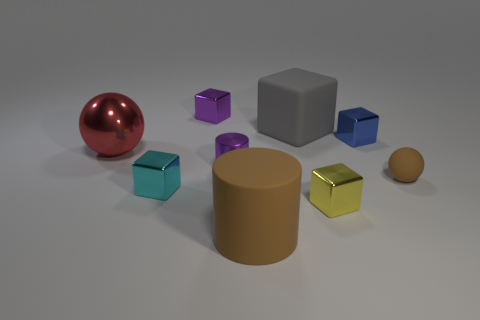What number of objects are either large matte things in front of the yellow cube or large matte cylinders?
Offer a terse response. 1. What is the material of the tiny cyan block in front of the brown object that is right of the yellow block?
Your answer should be compact. Metal. Is there a large metallic thing of the same shape as the small rubber thing?
Your response must be concise. Yes. There is a yellow cube; does it have the same size as the purple thing in front of the big red shiny object?
Provide a succinct answer. Yes. What number of objects are big brown cylinders left of the rubber sphere or tiny shiny objects in front of the gray rubber thing?
Provide a short and direct response. 5. Is the number of balls that are to the left of the small cyan shiny block greater than the number of large brown cubes?
Ensure brevity in your answer.  Yes. How many blue cylinders have the same size as the cyan metallic block?
Keep it short and to the point. 0. Does the ball in front of the red sphere have the same size as the yellow object in front of the tiny brown matte thing?
Your answer should be compact. Yes. How big is the purple object that is behind the red metal object?
Ensure brevity in your answer.  Small. There is a purple thing right of the purple thing behind the red object; how big is it?
Provide a short and direct response. Small. 